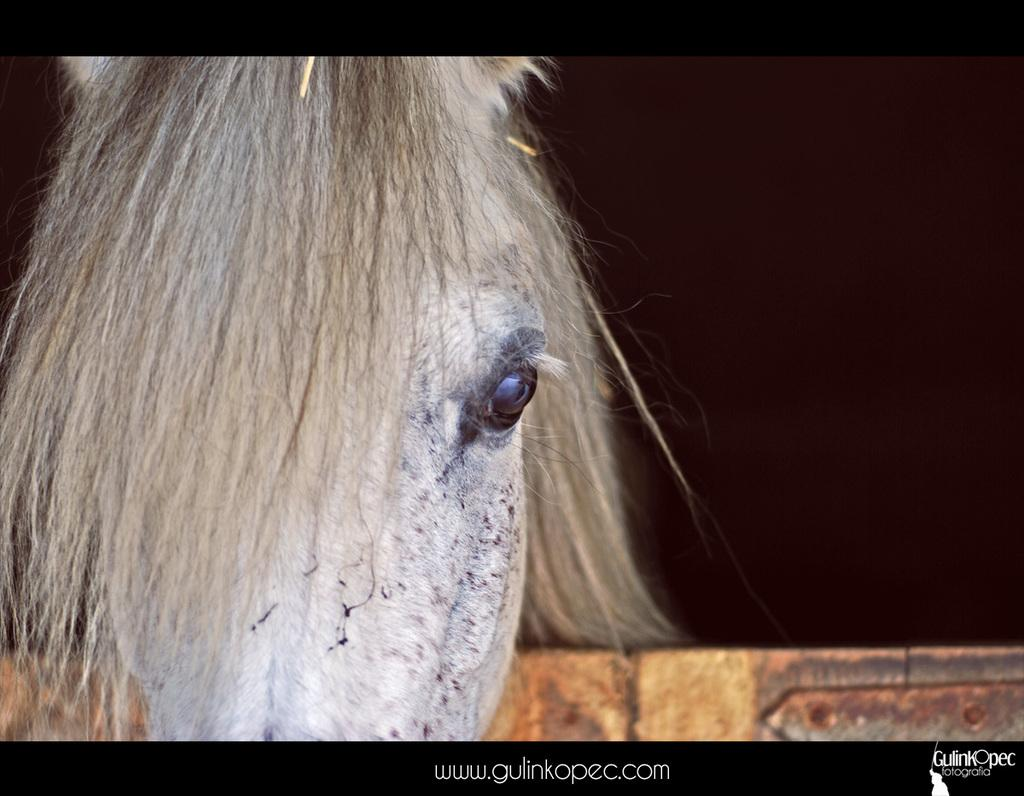What animal is the main subject of the image? There is a horse in the image. What is in front of the horse? There is a wooden fence in front of the horse. How would you describe the background of the image? The background of the image is dark. Is there any text present in the image? Yes, there is some text at the bottom of the image. Can you tell me how many babies are playing with the horse in the image? There are no babies present in the image, and the horse is not engaged in any playful activity. 